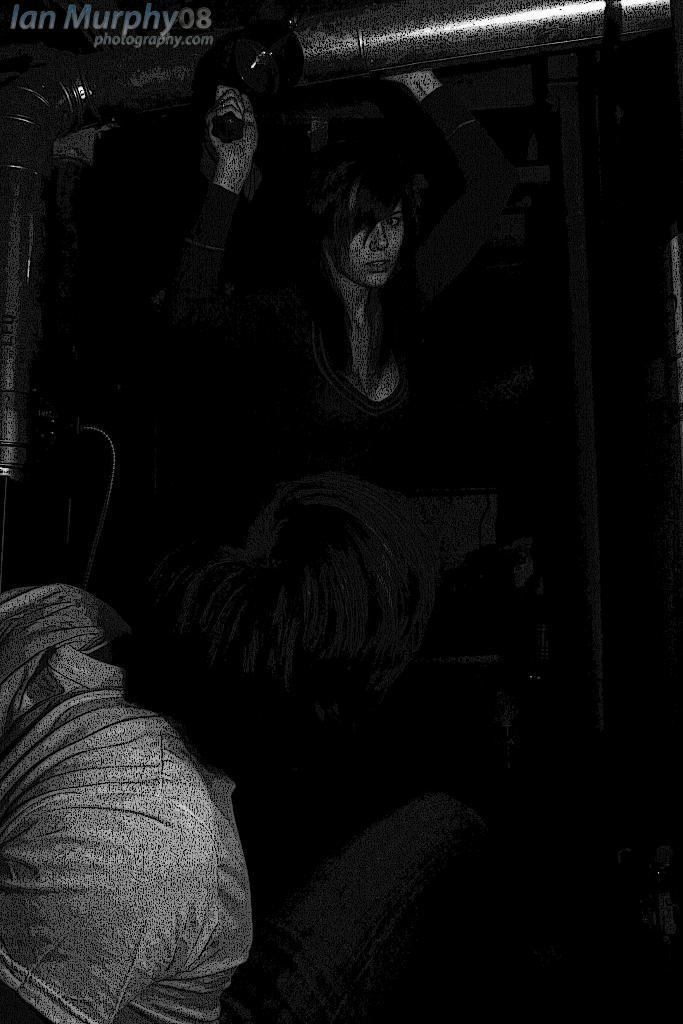Please provide a concise description of this image. In the picture we can see a poster on it, we can see a woman holding a pipe and holding something in the other hand and near to her we can see two people are standing in the dark. 